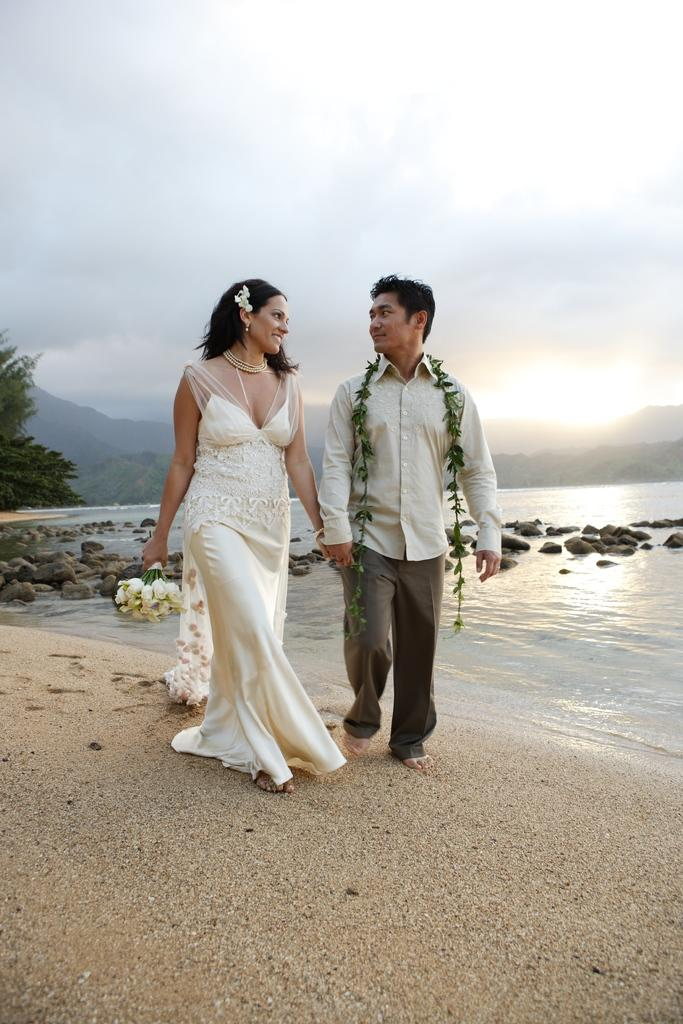Who is present in the image? There is a couple in the image. What are the couple doing in the image? The couple is walking on sand and holding hands. What can be seen in the background of the image? There are trees and mountains in the background of the background of the image. What is the terrain like in the image? The terrain includes sand, rocks, and water. What type of ticket is the couple holding in the image? There is no ticket present in the image; the couple is holding hands. What time of day is it in the image? The time of day is not specified in the image, but it could be any time of day. 